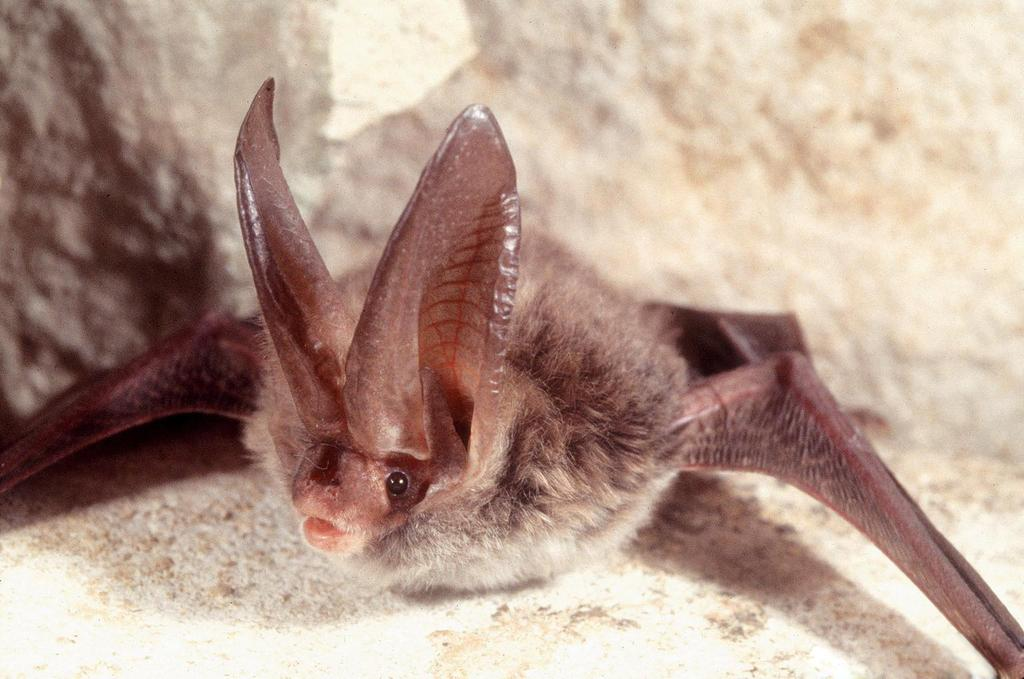What type of animal is in the image? The facts do not specify the type of animal, only that it is an animal and brown in color. What color is the animal in the image? The animal in the image is brown in color. What color is the background of the image? The background of the image is cream-colored. How does the animal experience a thrill in the image? The image does not depict the animal experiencing a thrill, nor does it provide any information about the animal's emotional state. 